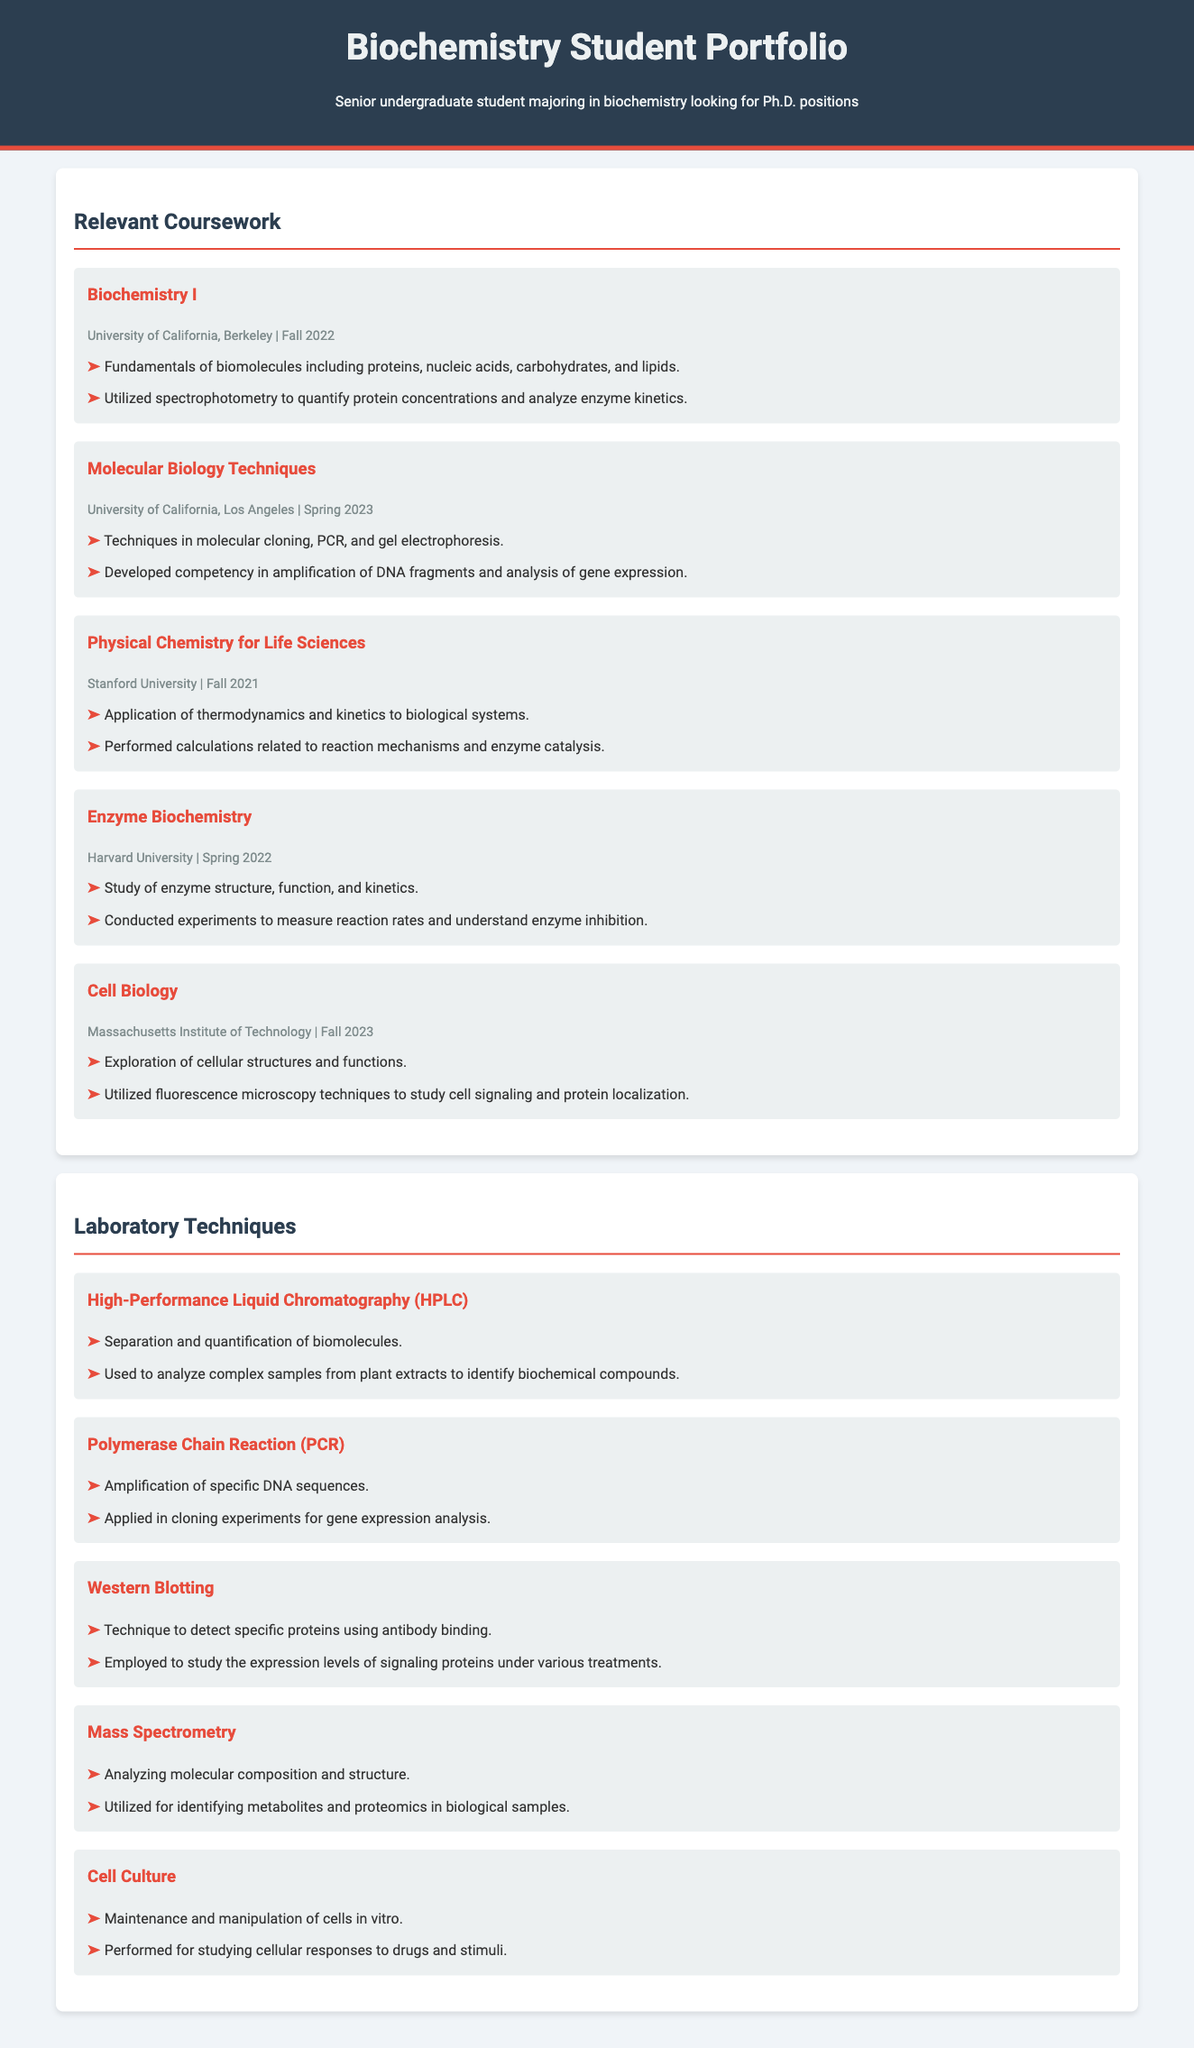What is the title of the portfolio? The title of the portfolio is displayed prominently at the top of the document.
Answer: Biochemistry Student Portfolio Which university offered the course "Enzyme Biochemistry"? The university offering "Enzyme Biochemistry" is mentioned alongside the course details.
Answer: Harvard University In which semester was "Molecular Biology Techniques" taken? The semester for "Molecular Biology Techniques" is indicated in the course information.
Answer: Spring 2023 What technique is used for analyzing molecular composition? The technique for analyzing molecular composition is listed in the laboratory techniques section.
Answer: Mass Spectrometry How many laboratory techniques are detailed in the document? The total number of laboratory techniques can be counted from the list provided in the document.
Answer: Five What application was stated for fluorescence microscopy? The application for fluorescence microscopy can be found under the relevant coursework description.
Answer: Study cell signaling and protein localization What is the focus of the course "Biochemistry I"? The focus of "Biochemistry I" is summarized in the course details section.
Answer: Fundamentals of biomolecules Which laboratory technique is associated with amplification of DNA sequences? The laboratory technique associated with DNA amplification is specified clearly in the document.
Answer: Polymerase Chain Reaction When was the course "Cell Biology" taken? The date for the completion of "Cell Biology" is provided in the course details.
Answer: Fall 2023 